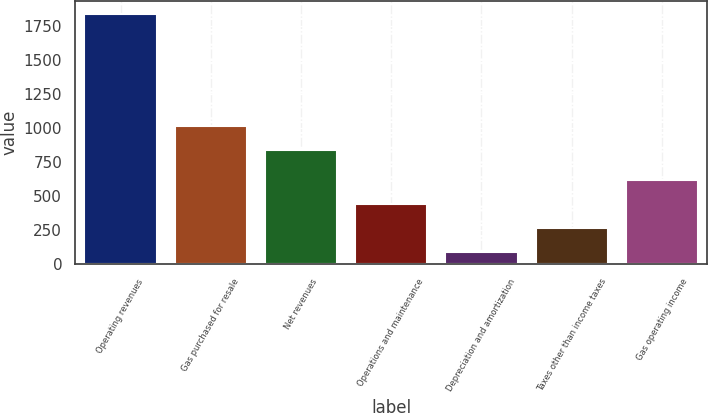<chart> <loc_0><loc_0><loc_500><loc_500><bar_chart><fcel>Operating revenues<fcel>Gas purchased for resale<fcel>Net revenues<fcel>Operations and maintenance<fcel>Depreciation and amortization<fcel>Taxes other than income taxes<fcel>Gas operating income<nl><fcel>1839<fcel>1014.9<fcel>840<fcel>439.8<fcel>90<fcel>264.9<fcel>614.7<nl></chart> 